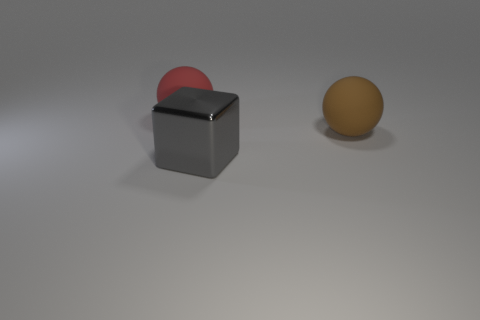Add 3 large yellow rubber cylinders. How many objects exist? 6 Subtract all red spheres. How many spheres are left? 1 Subtract all blocks. How many objects are left? 2 Subtract all tiny blue cylinders. Subtract all matte balls. How many objects are left? 1 Add 3 gray metal objects. How many gray metal objects are left? 4 Add 3 gray metal cubes. How many gray metal cubes exist? 4 Subtract 0 blue blocks. How many objects are left? 3 